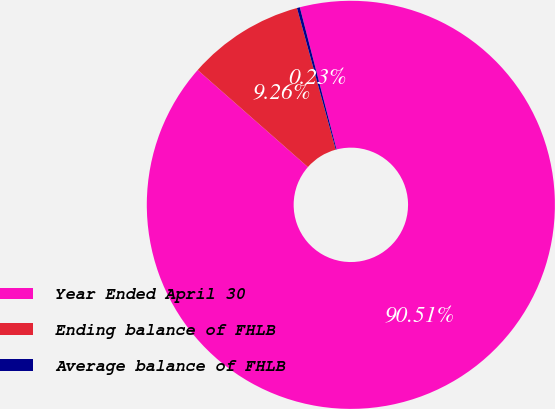Convert chart. <chart><loc_0><loc_0><loc_500><loc_500><pie_chart><fcel>Year Ended April 30<fcel>Ending balance of FHLB<fcel>Average balance of FHLB<nl><fcel>90.51%<fcel>9.26%<fcel>0.23%<nl></chart> 